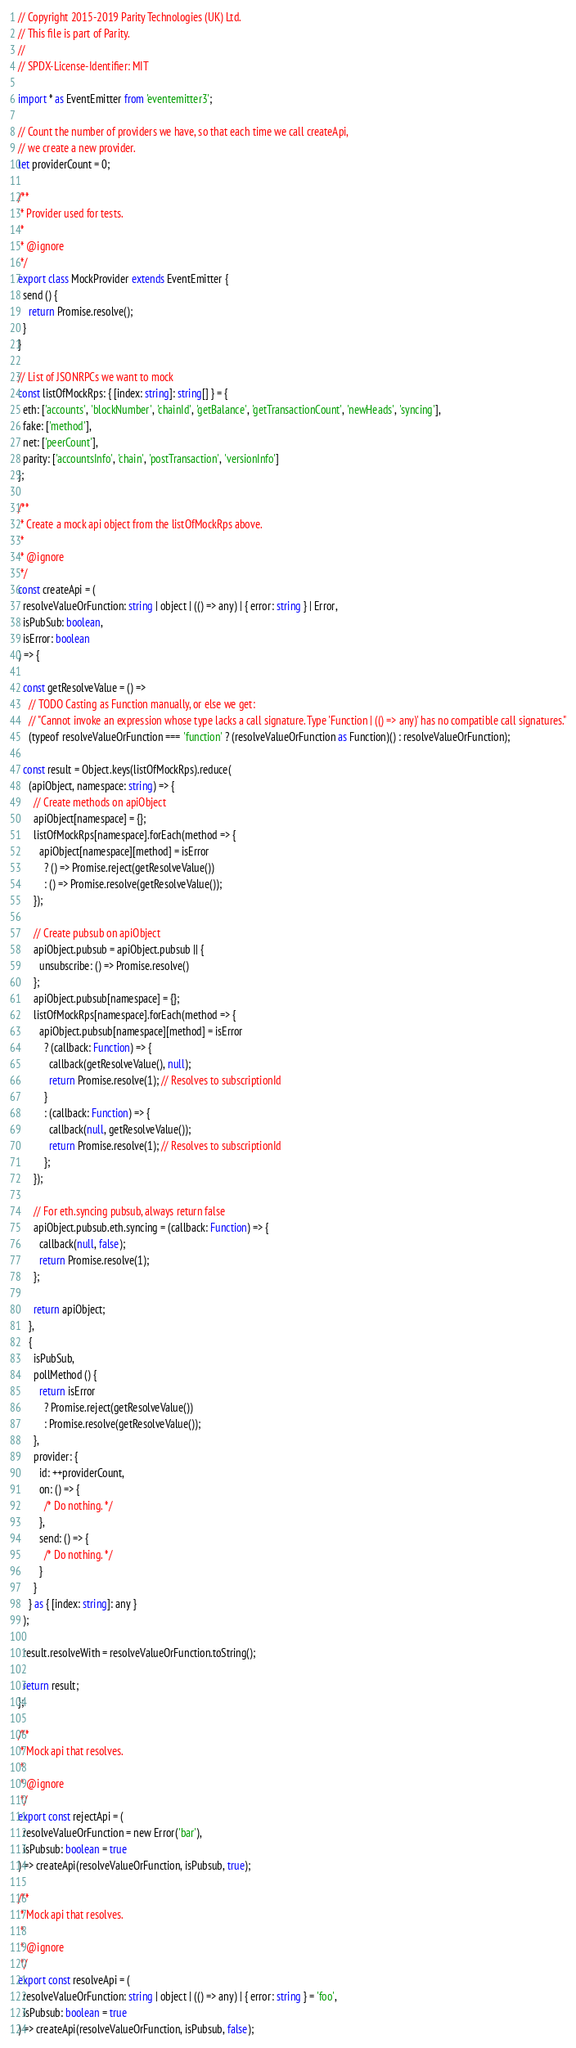Convert code to text. <code><loc_0><loc_0><loc_500><loc_500><_TypeScript_>// Copyright 2015-2019 Parity Technologies (UK) Ltd.
// This file is part of Parity.
//
// SPDX-License-Identifier: MIT

import * as EventEmitter from 'eventemitter3';

// Count the number of providers we have, so that each time we call createApi,
// we create a new provider.
let providerCount = 0;

/**
 * Provider used for tests.
 *
 * @ignore
 */
export class MockProvider extends EventEmitter {
  send () {
    return Promise.resolve();
  }
}

// List of JSONRPCs we want to mock
const listOfMockRps: { [index: string]: string[] } = {
  eth: ['accounts', 'blockNumber', 'chainId', 'getBalance', 'getTransactionCount', 'newHeads', 'syncing'],
  fake: ['method'],
  net: ['peerCount'],
  parity: ['accountsInfo', 'chain', 'postTransaction', 'versionInfo']
};

/**
 * Create a mock api object from the listOfMockRps above.
 *
 * @ignore
 */
const createApi = (
  resolveValueOrFunction: string | object | (() => any) | { error: string } | Error,
  isPubSub: boolean,
  isError: boolean
) => {

  const getResolveValue = () =>
    // TODO Casting as Function manually, or else we get:
    // "Cannot invoke an expression whose type lacks a call signature. Type 'Function | (() => any)' has no compatible call signatures."
    (typeof resolveValueOrFunction === 'function' ? (resolveValueOrFunction as Function)() : resolveValueOrFunction);

  const result = Object.keys(listOfMockRps).reduce(
    (apiObject, namespace: string) => {
      // Create methods on apiObject
      apiObject[namespace] = {};
      listOfMockRps[namespace].forEach(method => {
        apiObject[namespace][method] = isError
          ? () => Promise.reject(getResolveValue())
          : () => Promise.resolve(getResolveValue());
      });

      // Create pubsub on apiObject
      apiObject.pubsub = apiObject.pubsub || {
        unsubscribe: () => Promise.resolve()
      };
      apiObject.pubsub[namespace] = {};
      listOfMockRps[namespace].forEach(method => {
        apiObject.pubsub[namespace][method] = isError
          ? (callback: Function) => {
            callback(getResolveValue(), null);
            return Promise.resolve(1); // Resolves to subscriptionId
          }
          : (callback: Function) => {
            callback(null, getResolveValue());
            return Promise.resolve(1); // Resolves to subscriptionId
          };
      });

      // For eth.syncing pubsub, always return false
      apiObject.pubsub.eth.syncing = (callback: Function) => {
        callback(null, false);
        return Promise.resolve(1);
      };

      return apiObject;
    },
    {
      isPubSub,
      pollMethod () {
        return isError
          ? Promise.reject(getResolveValue())
          : Promise.resolve(getResolveValue());
      },
      provider: {
        id: ++providerCount,
        on: () => {
          /* Do nothing. */
        },
        send: () => {
          /* Do nothing. */
        }
      }
    } as { [index: string]: any }
  );

  result.resolveWith = resolveValueOrFunction.toString();

  return result;
};

/**
 * Mock api that resolves.
 *
 * @ignore
 */
export const rejectApi = (
  resolveValueOrFunction = new Error('bar'),
  isPubsub: boolean = true
) => createApi(resolveValueOrFunction, isPubsub, true);

/**
 * Mock api that resolves.
 *
 * @ignore
 */
export const resolveApi = (
  resolveValueOrFunction: string | object | (() => any) | { error: string } = 'foo',
  isPubsub: boolean = true
) => createApi(resolveValueOrFunction, isPubsub, false);
</code> 